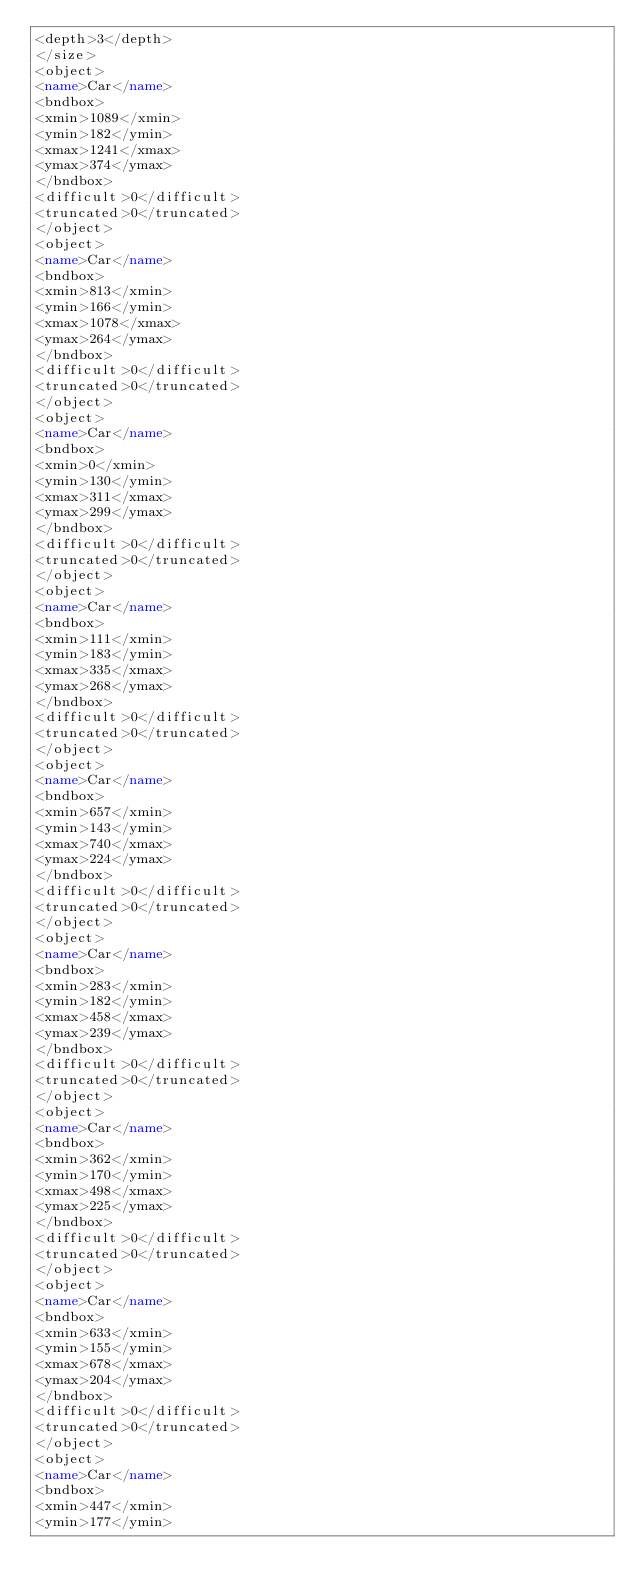Convert code to text. <code><loc_0><loc_0><loc_500><loc_500><_XML_><depth>3</depth>
</size>
<object>
<name>Car</name>
<bndbox>
<xmin>1089</xmin>
<ymin>182</ymin>
<xmax>1241</xmax>
<ymax>374</ymax>
</bndbox>
<difficult>0</difficult>
<truncated>0</truncated>
</object>
<object>
<name>Car</name>
<bndbox>
<xmin>813</xmin>
<ymin>166</ymin>
<xmax>1078</xmax>
<ymax>264</ymax>
</bndbox>
<difficult>0</difficult>
<truncated>0</truncated>
</object>
<object>
<name>Car</name>
<bndbox>
<xmin>0</xmin>
<ymin>130</ymin>
<xmax>311</xmax>
<ymax>299</ymax>
</bndbox>
<difficult>0</difficult>
<truncated>0</truncated>
</object>
<object>
<name>Car</name>
<bndbox>
<xmin>111</xmin>
<ymin>183</ymin>
<xmax>335</xmax>
<ymax>268</ymax>
</bndbox>
<difficult>0</difficult>
<truncated>0</truncated>
</object>
<object>
<name>Car</name>
<bndbox>
<xmin>657</xmin>
<ymin>143</ymin>
<xmax>740</xmax>
<ymax>224</ymax>
</bndbox>
<difficult>0</difficult>
<truncated>0</truncated>
</object>
<object>
<name>Car</name>
<bndbox>
<xmin>283</xmin>
<ymin>182</ymin>
<xmax>458</xmax>
<ymax>239</ymax>
</bndbox>
<difficult>0</difficult>
<truncated>0</truncated>
</object>
<object>
<name>Car</name>
<bndbox>
<xmin>362</xmin>
<ymin>170</ymin>
<xmax>498</xmax>
<ymax>225</ymax>
</bndbox>
<difficult>0</difficult>
<truncated>0</truncated>
</object>
<object>
<name>Car</name>
<bndbox>
<xmin>633</xmin>
<ymin>155</ymin>
<xmax>678</xmax>
<ymax>204</ymax>
</bndbox>
<difficult>0</difficult>
<truncated>0</truncated>
</object>
<object>
<name>Car</name>
<bndbox>
<xmin>447</xmin>
<ymin>177</ymin></code> 